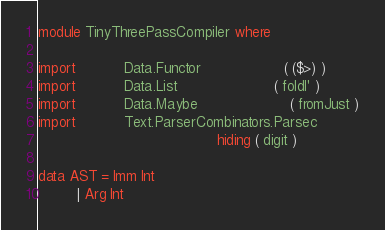Convert code to text. <code><loc_0><loc_0><loc_500><loc_500><_Haskell_>module TinyThreePassCompiler where

import           Data.Functor                   ( ($>) )
import           Data.List                      ( foldl' )
import           Data.Maybe                     ( fromJust )
import           Text.ParserCombinators.Parsec
                                         hiding ( digit )

data AST = Imm Int
         | Arg Int</code> 